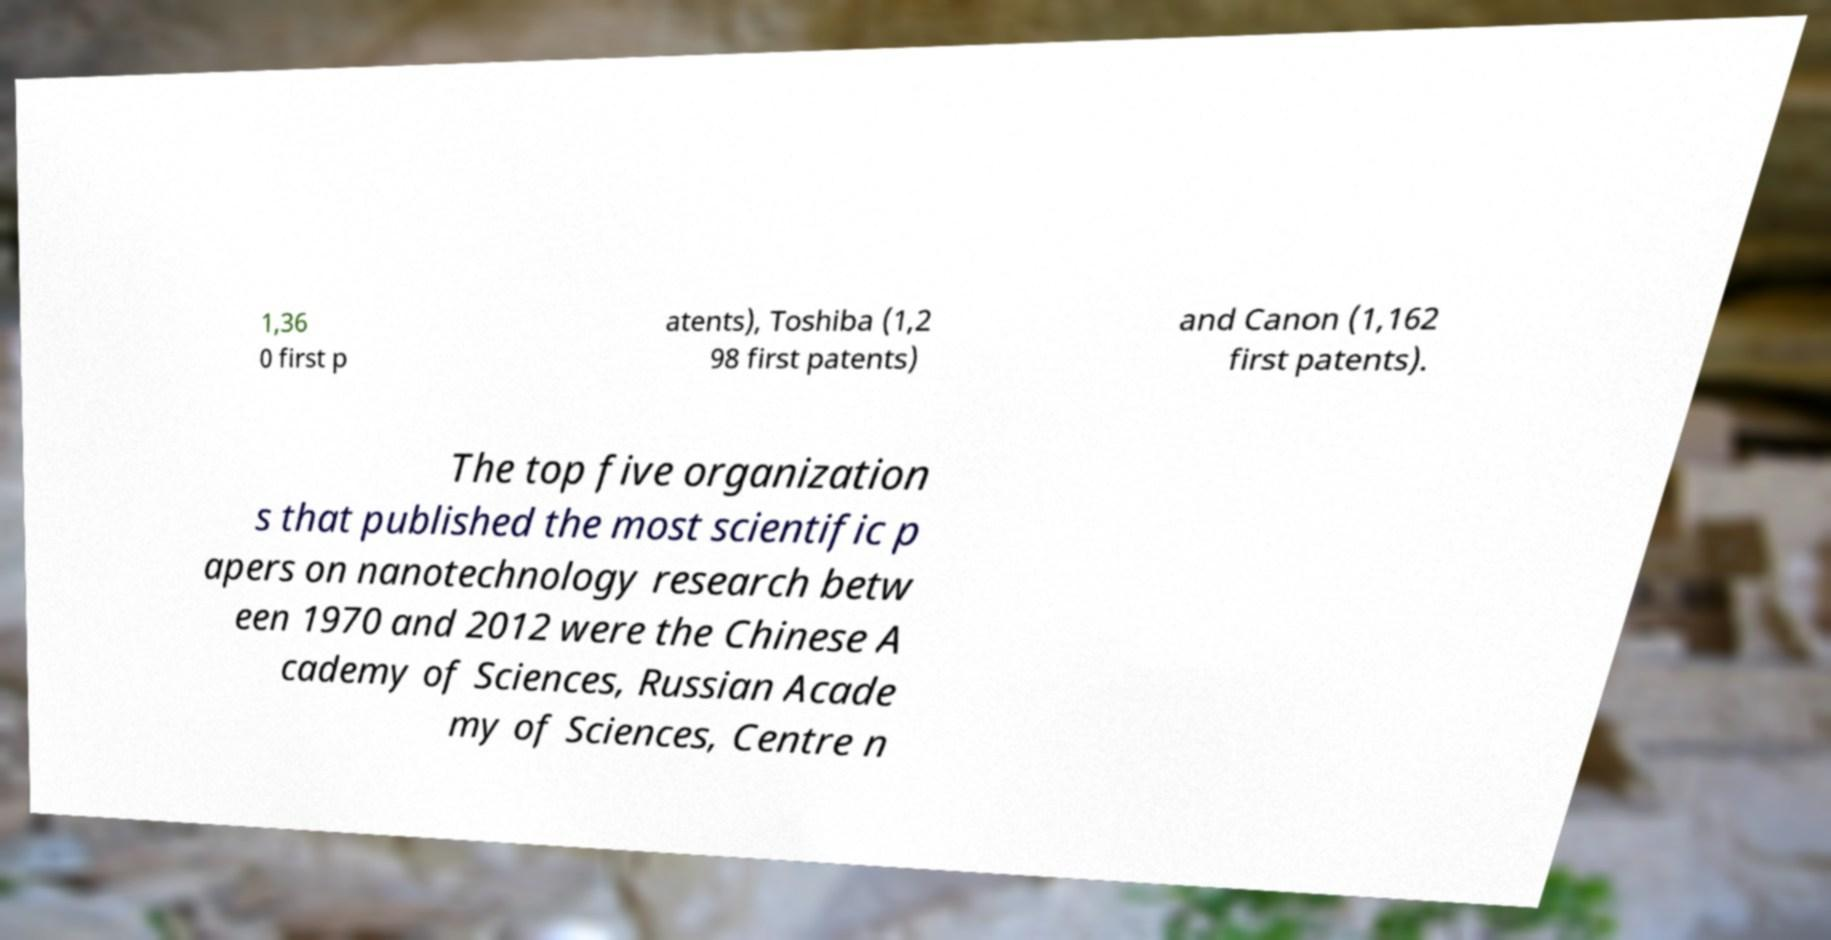Please read and relay the text visible in this image. What does it say? 1,36 0 first p atents), Toshiba (1,2 98 first patents) and Canon (1,162 first patents). The top five organization s that published the most scientific p apers on nanotechnology research betw een 1970 and 2012 were the Chinese A cademy of Sciences, Russian Acade my of Sciences, Centre n 